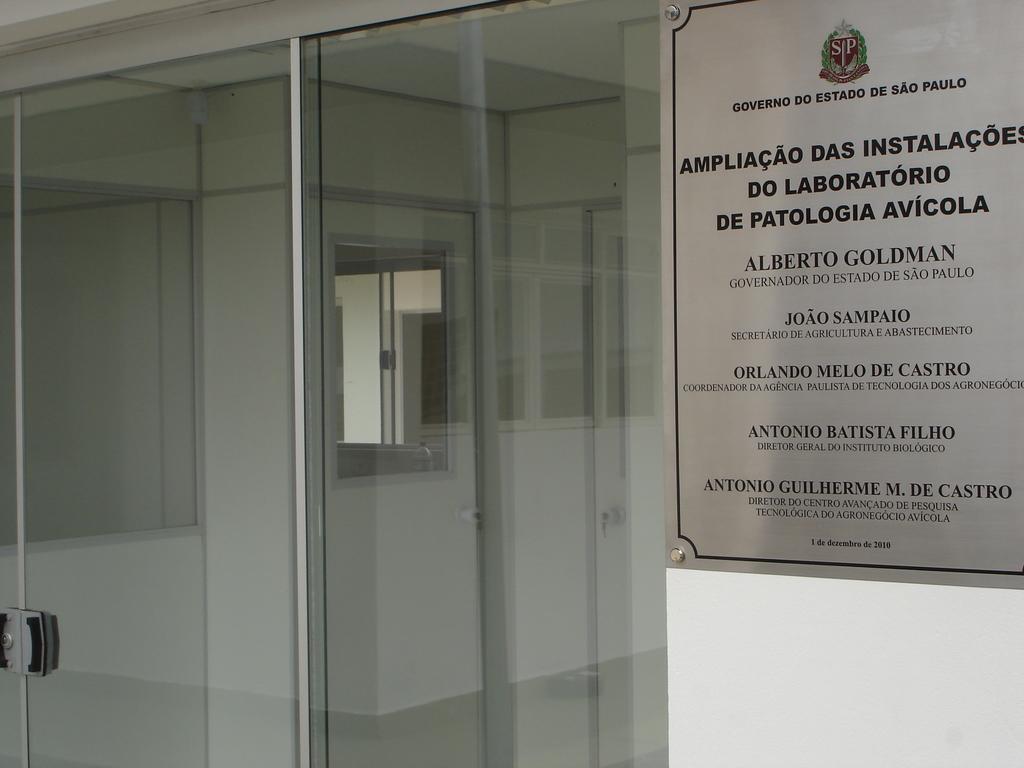What is the first person's name on the sign?
Make the answer very short. Alberto goldman. 